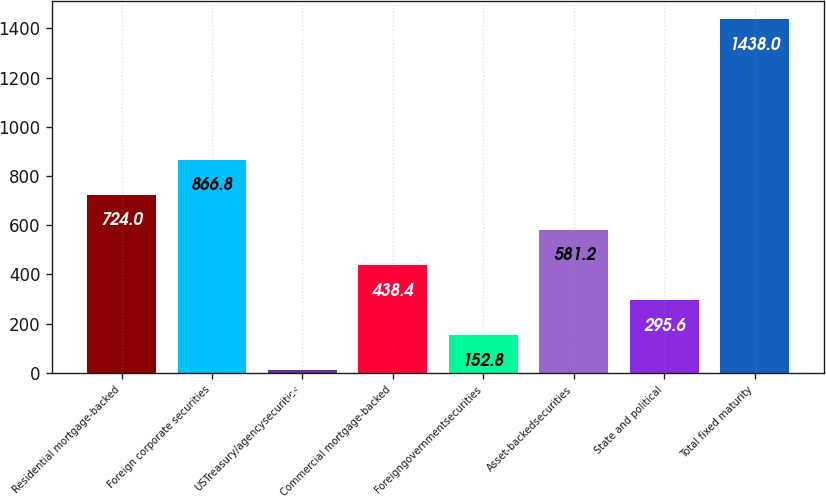Convert chart. <chart><loc_0><loc_0><loc_500><loc_500><bar_chart><fcel>Residential mortgage-backed<fcel>Foreign corporate securities<fcel>USTreasury/agencysecurities<fcel>Commercial mortgage-backed<fcel>Foreigngovernmentsecurities<fcel>Asset-backedsecurities<fcel>State and political<fcel>Total fixed maturity<nl><fcel>724<fcel>866.8<fcel>10<fcel>438.4<fcel>152.8<fcel>581.2<fcel>295.6<fcel>1438<nl></chart> 